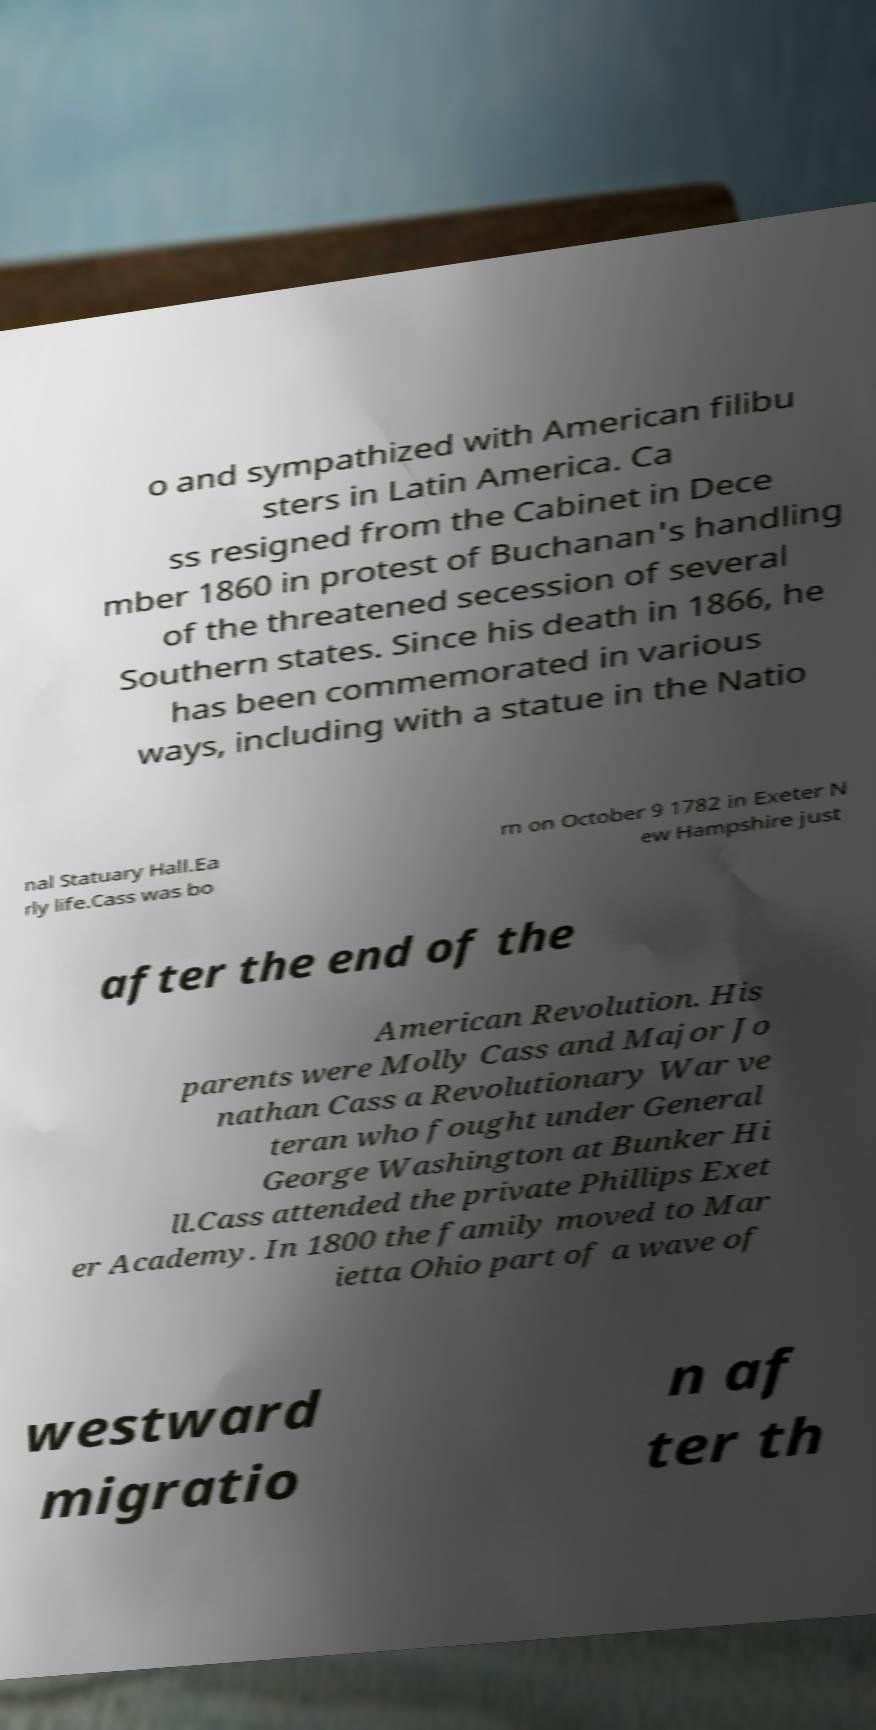Can you read and provide the text displayed in the image?This photo seems to have some interesting text. Can you extract and type it out for me? o and sympathized with American filibu sters in Latin America. Ca ss resigned from the Cabinet in Dece mber 1860 in protest of Buchanan's handling of the threatened secession of several Southern states. Since his death in 1866, he has been commemorated in various ways, including with a statue in the Natio nal Statuary Hall.Ea rly life.Cass was bo rn on October 9 1782 in Exeter N ew Hampshire just after the end of the American Revolution. His parents were Molly Cass and Major Jo nathan Cass a Revolutionary War ve teran who fought under General George Washington at Bunker Hi ll.Cass attended the private Phillips Exet er Academy. In 1800 the family moved to Mar ietta Ohio part of a wave of westward migratio n af ter th 